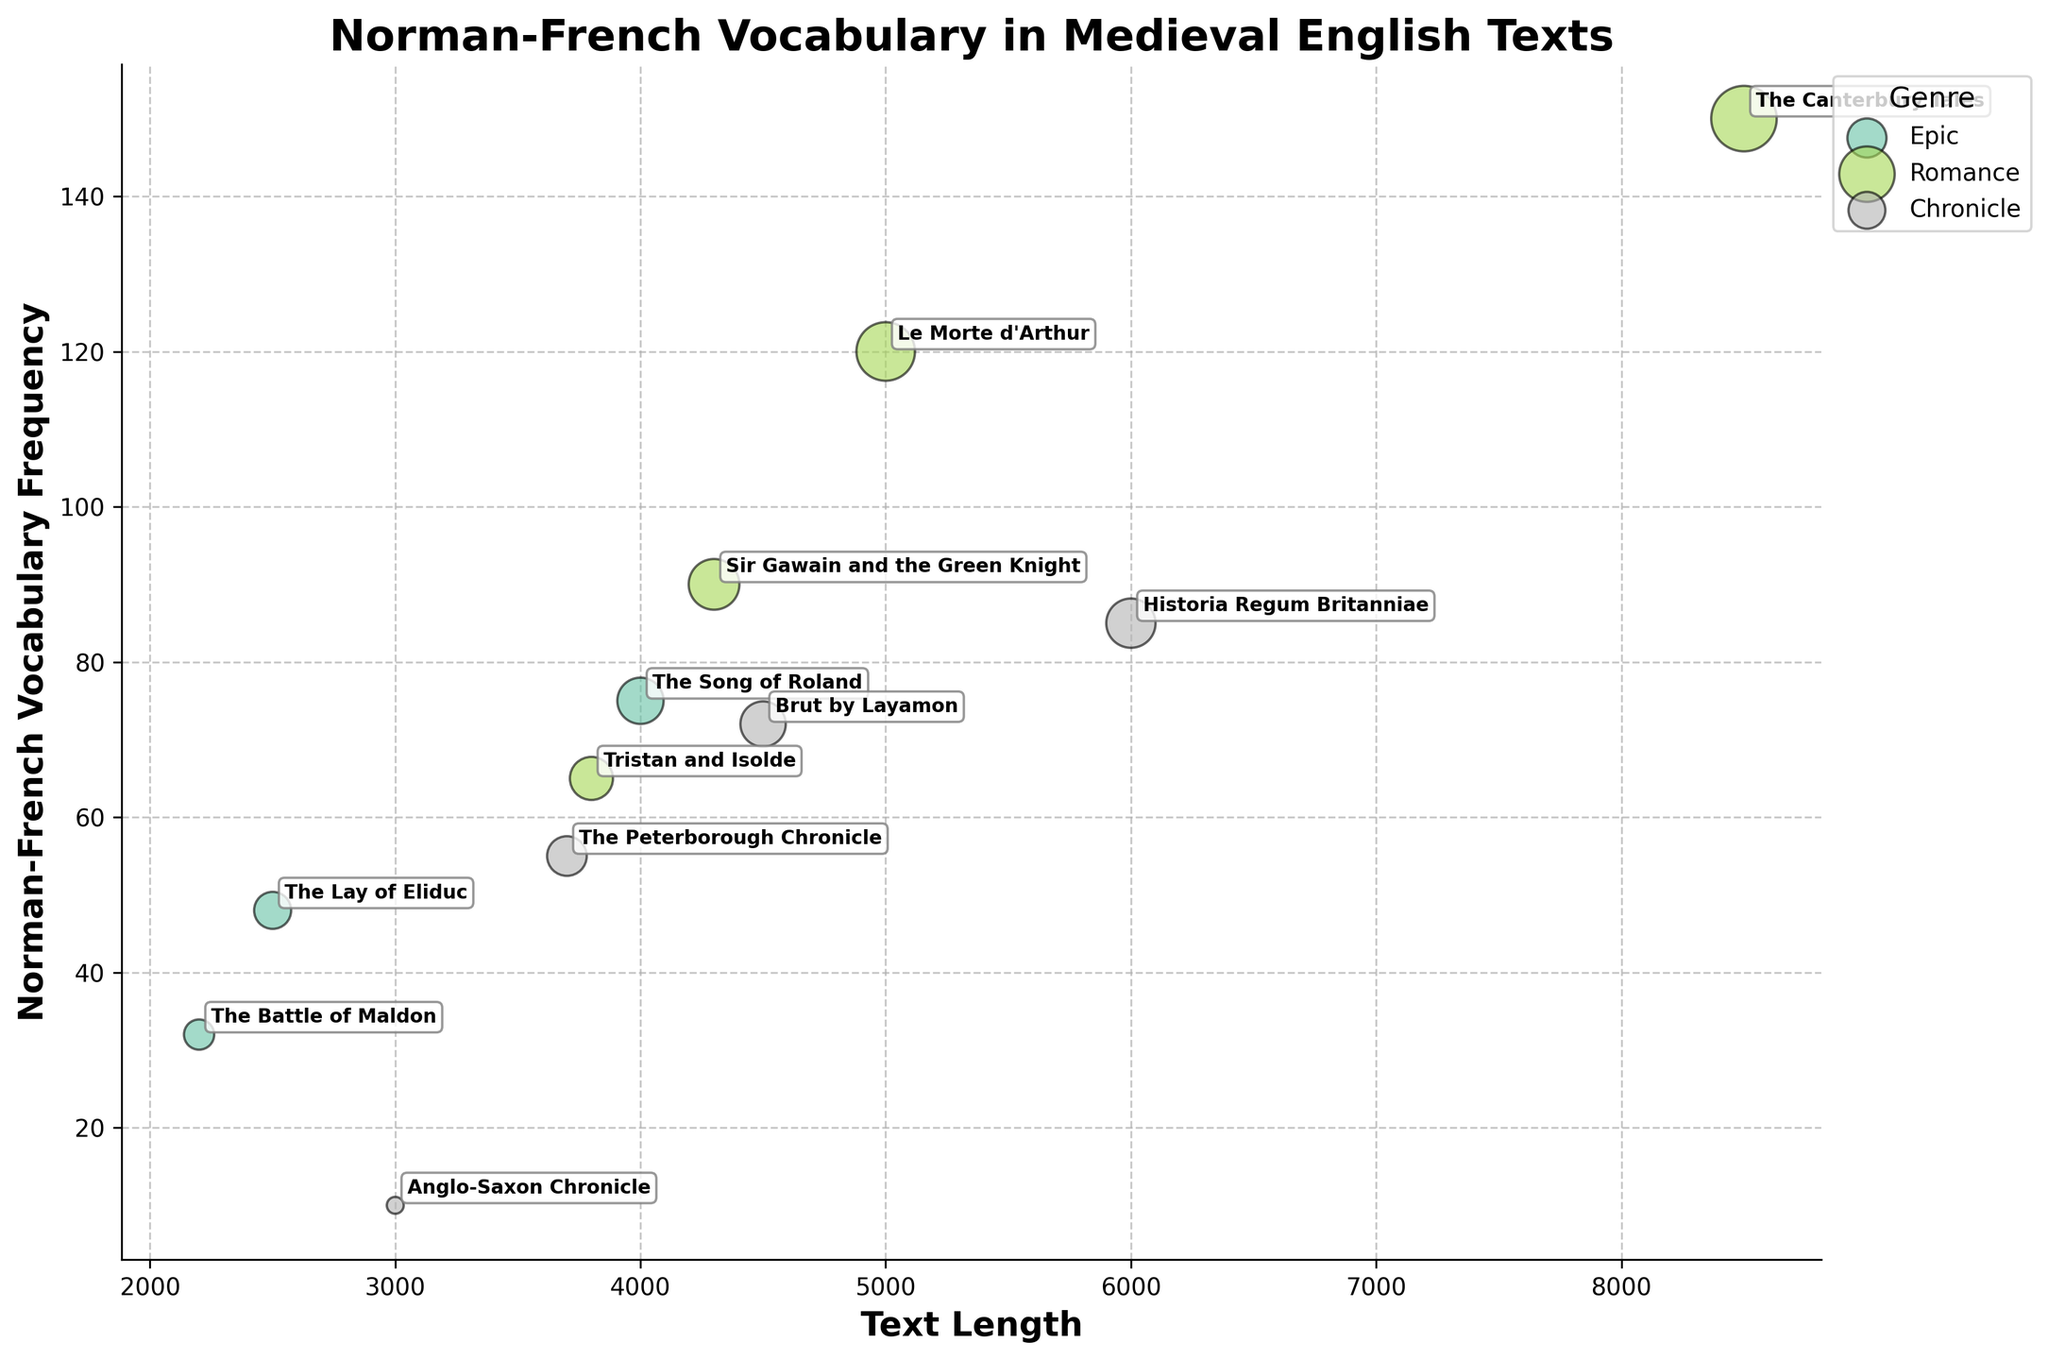What is the title of the chart? The title of the chart is displayed at the top, often in a larger font size to make it distinguishable from other text. It reads, "Norman-French Vocabulary in Medieval English Texts."
Answer: Norman-French Vocabulary in Medieval English Texts Which genre has the highest frequency of Norman-French vocabulary? To determine the genre with the highest frequency, look for the bubble positioned highest along the y-axis. The largest frequency of 150 is associated with "The Canterbury Tales," which falls under the Romance genre.
Answer: Romance How many genres are represented in the chart? The chart legend, typically on the right, names each genre. There are four genres listed: Epic, Romance, Chronicle, and one more.
Answer: Four Which text has the largest bubble size, and what is its frequency of Norman-French vocabulary? The bubble size correlates with the Norman-French Vocabulary Frequency — the largest bubble will correspond to the highest value on the y-axis, which is "The Canterbury Tales" with a frequency of 150.
Answer: The Canterbury Tales, 150 Compare the Norman-French vocabulary frequency of "The Song of Roland" and "Sir Gawain and the Green Knight." Which one is higher and by how much? "The Song of Roland" and "Sir Gawain and the Green Knight" both fall on the y-axis at 75 and 90, respectively. Subtract 75 from 90 to determine the difference.
Answer: Sir Gawain and the Green Knight, by 15 Calculate the average text length across all Romance texts. Find the text lengths of each Romance text: 5000, 3800, 4300, 8500. Sum them (5000 + 3800 + 4300 + 8500 = 21600) and divide by the total number of Romance texts (4).
Answer: 5400 Which text in the Chronicle genre has the lowest frequency of Norman-French vocabulary? Among the Chronicle genre texts, find the smallest y-axis value. "Anglo-Saxon Chronicle," with a frequency of 10, is the lowest within its genre.
Answer: Anglo-Saxon Chronicle What is the total Norman-French vocabulary frequency for all Epic texts combined? Sum the frequencies of all Epic texts: "The Song of Roland" (75), "The Lay of Eliduc" (48), "The Battle of Maldon" (32). Calculate 75 + 48 + 32.
Answer: 155 Is there any text with a Norman-French vocabulary frequency lower than 20? If so, which one? Look for any bubbles below the 20 mark on the y-axis. "Anglo-Saxon Chronicle" has a frequency of 10.
Answer: Anglo-Saxon Chronicle Identify the text with the longest length in the Romance genre and its corresponding Norman-French vocabulary frequency. Locate the Romance bubbles and find the one furthest to the right on the x-axis. "The Canterbury Tales" with a length of 8500 and a frequency of 150.
Answer: The Canterbury Tales, 150 